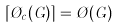Convert formula to latex. <formula><loc_0><loc_0><loc_500><loc_500>\lceil \chi _ { c } ( G ) \rceil = \chi ( G )</formula> 